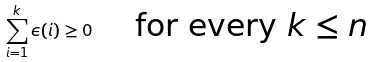<formula> <loc_0><loc_0><loc_500><loc_500>\sum _ { i = 1 } ^ { k } \epsilon ( i ) \geq 0 \quad \text { for every $k \leq n$}</formula> 